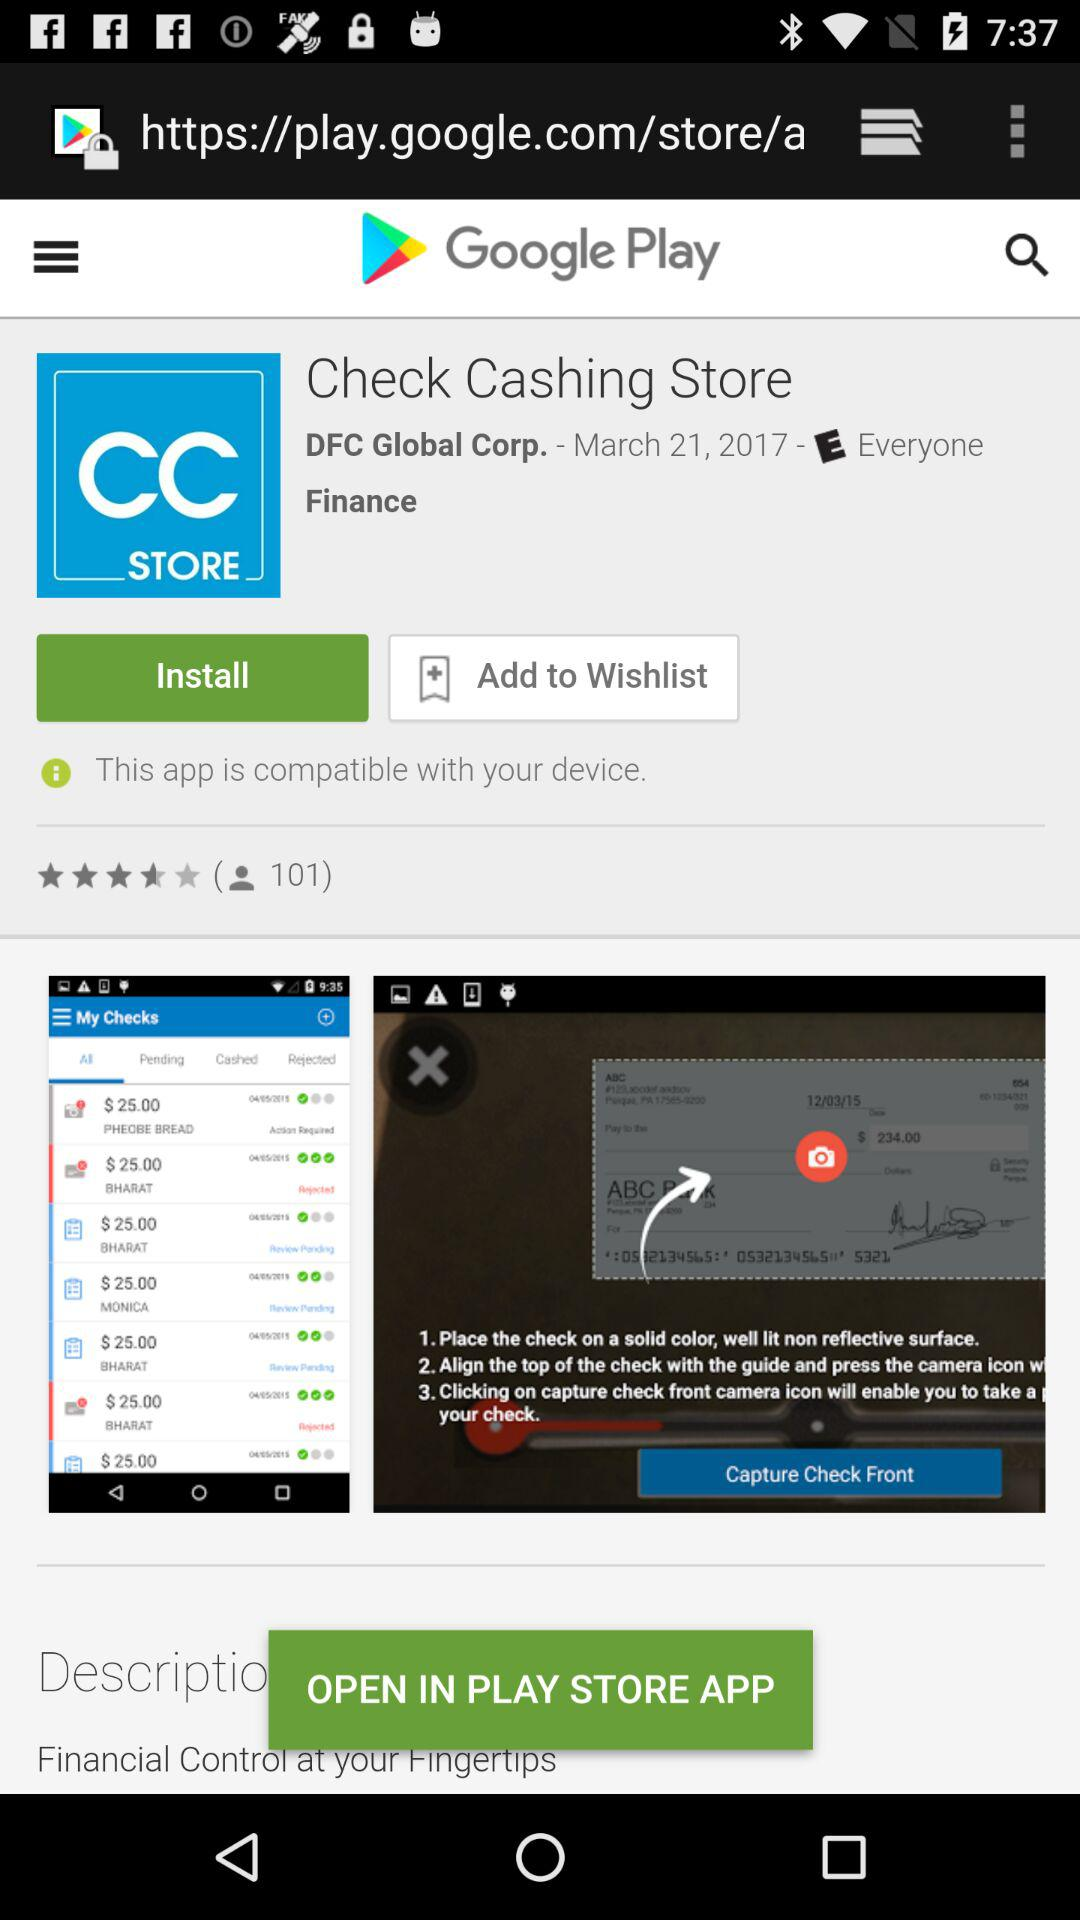What is the star rating of the application "Check Cashing Store"? The rating of the application "Check Cashing Store" is 4.5 stars. 